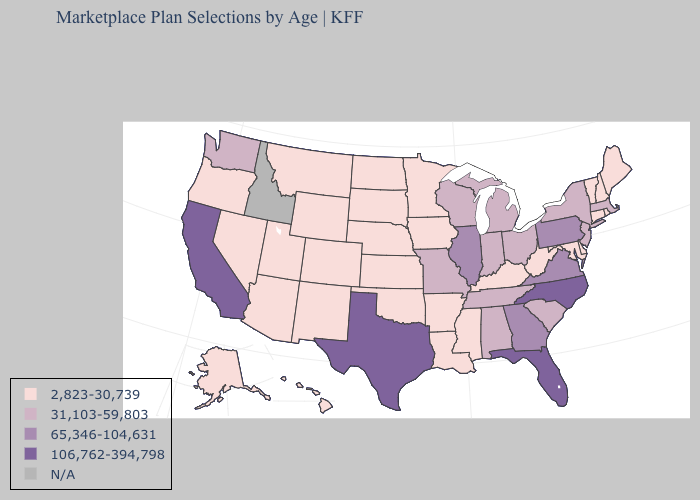What is the lowest value in the USA?
Quick response, please. 2,823-30,739. Which states have the highest value in the USA?
Give a very brief answer. California, Florida, North Carolina, Texas. Which states have the lowest value in the MidWest?
Quick response, please. Iowa, Kansas, Minnesota, Nebraska, North Dakota, South Dakota. Which states have the lowest value in the USA?
Write a very short answer. Alaska, Arizona, Arkansas, Colorado, Connecticut, Delaware, Hawaii, Iowa, Kansas, Kentucky, Louisiana, Maine, Maryland, Minnesota, Mississippi, Montana, Nebraska, Nevada, New Hampshire, New Mexico, North Dakota, Oklahoma, Oregon, Rhode Island, South Dakota, Utah, Vermont, West Virginia, Wyoming. What is the highest value in the West ?
Short answer required. 106,762-394,798. What is the lowest value in the South?
Give a very brief answer. 2,823-30,739. Among the states that border South Carolina , which have the highest value?
Keep it brief. North Carolina. Name the states that have a value in the range N/A?
Answer briefly. Idaho. Is the legend a continuous bar?
Be succinct. No. Does the map have missing data?
Be succinct. Yes. Does the map have missing data?
Keep it brief. Yes. How many symbols are there in the legend?
Give a very brief answer. 5. Does the first symbol in the legend represent the smallest category?
Keep it brief. Yes. Which states hav the highest value in the South?
Keep it brief. Florida, North Carolina, Texas. What is the value of Nevada?
Answer briefly. 2,823-30,739. 